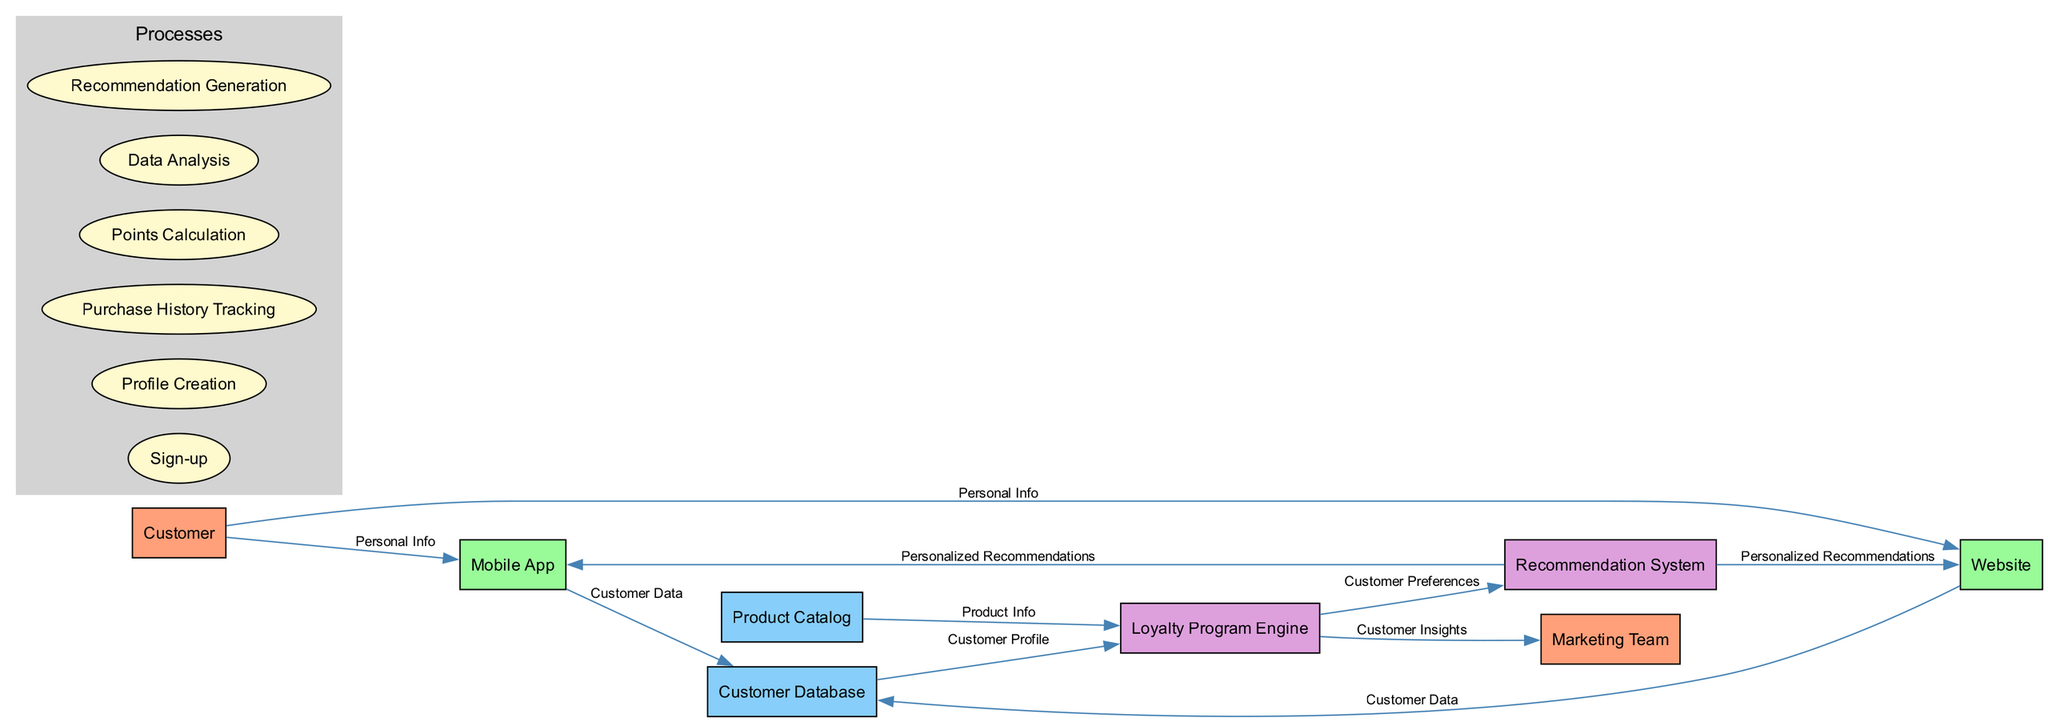What are the main entities in the diagram? The entities listed in the diagram are Customer, Mobile App, Website, Customer Database, Loyalty Program Engine, Product Catalog, Recommendation System, and Marketing Team.
Answer: Customer, Mobile App, Website, Customer Database, Loyalty Program Engine, Product Catalog, Recommendation System, Marketing Team How many processes are defined in the diagram? The diagram contains six distinct processes: Sign-up, Profile Creation, Purchase History Tracking, Points Calculation, Data Analysis, and Recommendation Generation.
Answer: Six What type of information flows from the Customer to the Mobile App? The flow labeled "Personal Info" indicates that the Customer sends personal information to the Mobile App.
Answer: Personal Info Which system receives Customer Preferences from the Loyalty Program Engine? The Recommendation System receives Customer Preferences directly from the Loyalty Program Engine, as indicated by the data flow in the diagram.
Answer: Recommendation System What is the output directed to the Marketing Team from the Loyalty Program Engine? The data labeled "Customer Insights" flows from the Loyalty Program Engine to the Marketing Team, representing valuable insights regarding customers gathered by the engine.
Answer: Customer Insights How does the Recommendation System deliver personalized suggestions to users? The Recommendation System supplies Personalized Recommendations to both the Mobile App and the Website, indicating that recommendations are presented through these platforms for user interaction.
Answer: Mobile App and Website What is the purpose of the points calculation in the loyalty program? Points Calculation is crucial for keeping track of the customer’s loyalty points, which can influence rewards and offers available to the customer.
Answer: Calculate loyalty points Which two platforms can customers use to submit their personal information? Customers can provide personal information through both the Mobile App and the Website, as shown by the respective data flows from the Customer to these platforms.
Answer: Mobile App and Website How many data flows are represented in the diagram? The diagram displays ten distinct data flows that illustrate various interactions and information exchanges within the loyalty program process.
Answer: Ten 